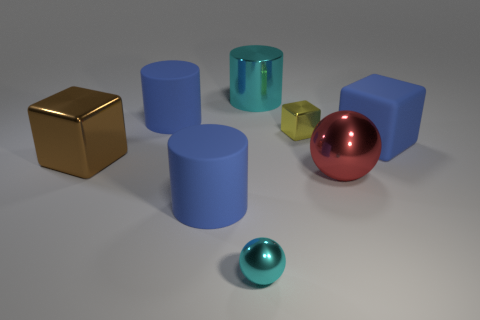Subtract all shiny cylinders. How many cylinders are left? 2 Subtract all green blocks. How many blue cylinders are left? 2 Add 2 big shiny objects. How many objects exist? 10 Subtract all green cylinders. Subtract all yellow spheres. How many cylinders are left? 3 Subtract all spheres. How many objects are left? 6 Subtract all tiny metal cylinders. Subtract all small metal spheres. How many objects are left? 7 Add 3 big brown shiny cubes. How many big brown shiny cubes are left? 4 Add 3 cyan spheres. How many cyan spheres exist? 4 Subtract 0 cyan blocks. How many objects are left? 8 